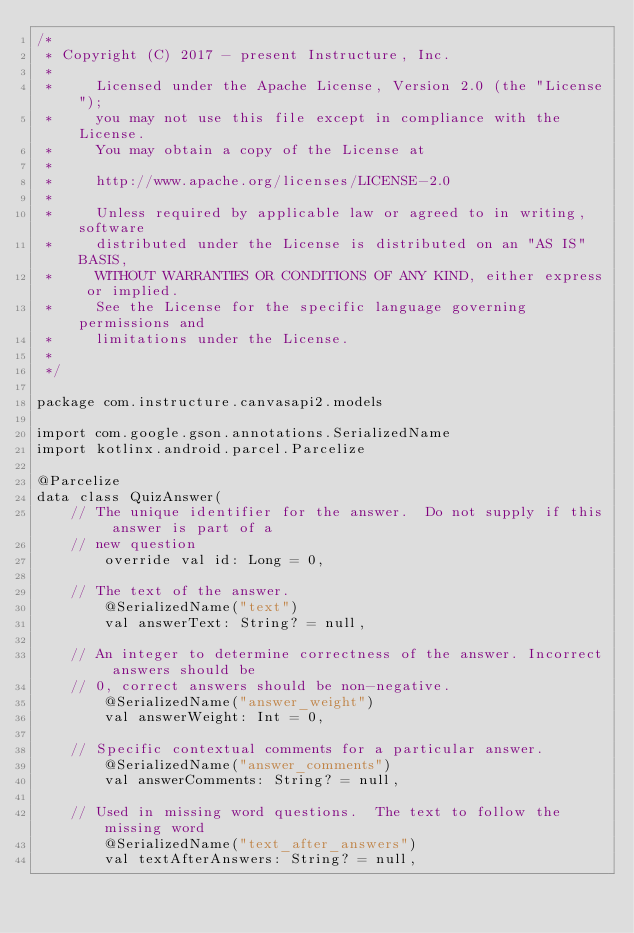Convert code to text. <code><loc_0><loc_0><loc_500><loc_500><_Kotlin_>/*
 * Copyright (C) 2017 - present Instructure, Inc.
 *
 *     Licensed under the Apache License, Version 2.0 (the "License");
 *     you may not use this file except in compliance with the License.
 *     You may obtain a copy of the License at
 *
 *     http://www.apache.org/licenses/LICENSE-2.0
 *
 *     Unless required by applicable law or agreed to in writing, software
 *     distributed under the License is distributed on an "AS IS" BASIS,
 *     WITHOUT WARRANTIES OR CONDITIONS OF ANY KIND, either express or implied.
 *     See the License for the specific language governing permissions and
 *     limitations under the License.
 *
 */

package com.instructure.canvasapi2.models

import com.google.gson.annotations.SerializedName
import kotlinx.android.parcel.Parcelize

@Parcelize
data class QuizAnswer(
    // The unique identifier for the answer.  Do not supply if this answer is part of a
    // new question
        override val id: Long = 0,

    // The text of the answer.
        @SerializedName("text")
        val answerText: String? = null,

    // An integer to determine correctness of the answer. Incorrect answers should be
    // 0, correct answers should be non-negative.
        @SerializedName("answer_weight")
        val answerWeight: Int = 0,

    // Specific contextual comments for a particular answer.
        @SerializedName("answer_comments")
        val answerComments: String? = null,

    // Used in missing word questions.  The text to follow the missing word
        @SerializedName("text_after_answers")
        val textAfterAnswers: String? = null,
</code> 